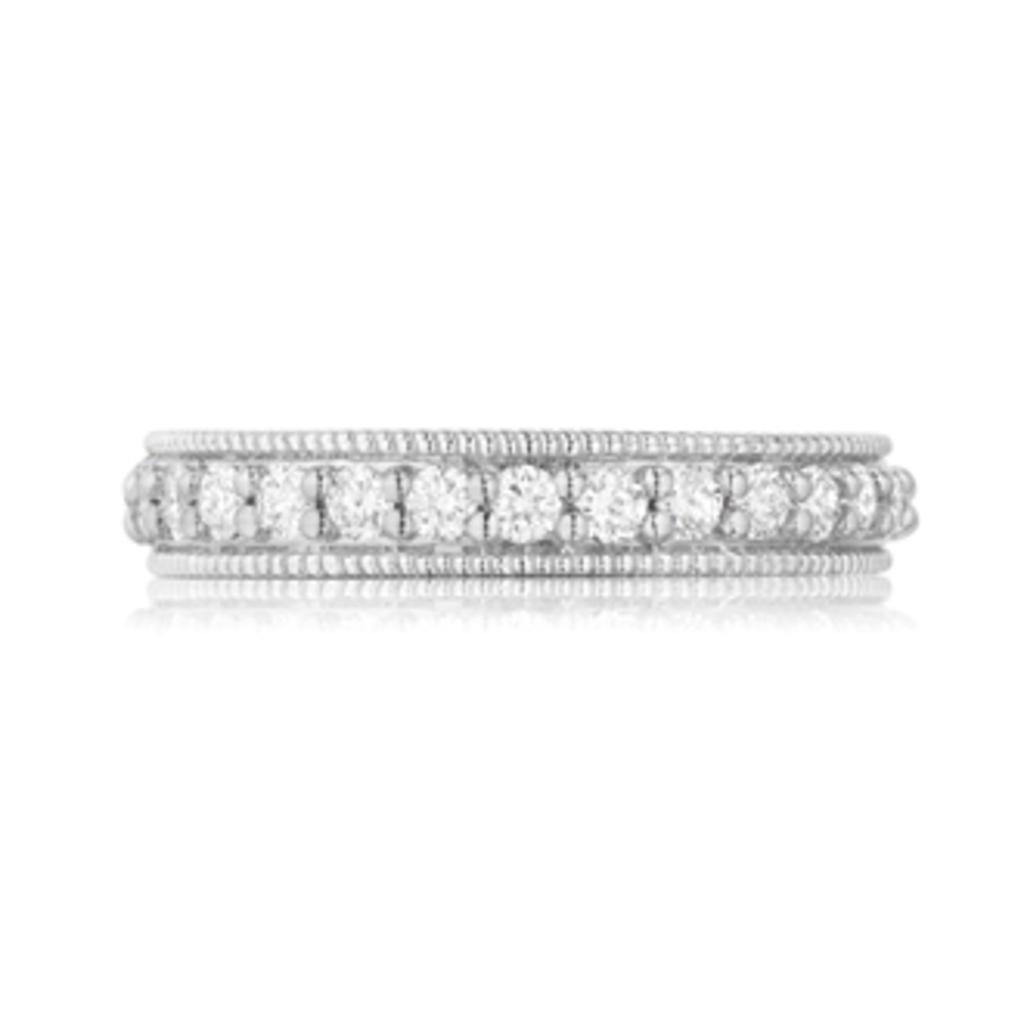Please provide a concise description of this image. In this picture I can see a bangle. The background of the image is white in color. 